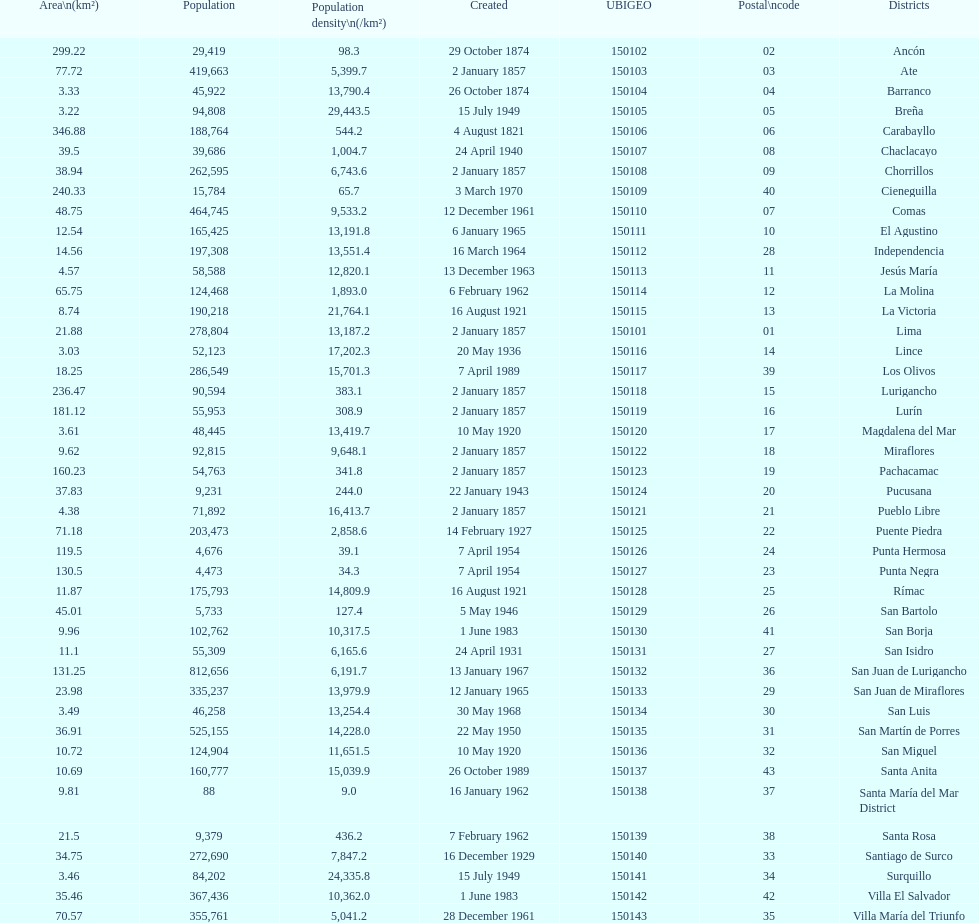Would you mind parsing the complete table? {'header': ['Area\\n(km²)', 'Population', 'Population density\\n(/km²)', 'Created', 'UBIGEO', 'Postal\\ncode', 'Districts'], 'rows': [['299.22', '29,419', '98.3', '29 October 1874', '150102', '02', 'Ancón'], ['77.72', '419,663', '5,399.7', '2 January 1857', '150103', '03', 'Ate'], ['3.33', '45,922', '13,790.4', '26 October 1874', '150104', '04', 'Barranco'], ['3.22', '94,808', '29,443.5', '15 July 1949', '150105', '05', 'Breña'], ['346.88', '188,764', '544.2', '4 August 1821', '150106', '06', 'Carabayllo'], ['39.5', '39,686', '1,004.7', '24 April 1940', '150107', '08', 'Chaclacayo'], ['38.94', '262,595', '6,743.6', '2 January 1857', '150108', '09', 'Chorrillos'], ['240.33', '15,784', '65.7', '3 March 1970', '150109', '40', 'Cieneguilla'], ['48.75', '464,745', '9,533.2', '12 December 1961', '150110', '07', 'Comas'], ['12.54', '165,425', '13,191.8', '6 January 1965', '150111', '10', 'El Agustino'], ['14.56', '197,308', '13,551.4', '16 March 1964', '150112', '28', 'Independencia'], ['4.57', '58,588', '12,820.1', '13 December 1963', '150113', '11', 'Jesús María'], ['65.75', '124,468', '1,893.0', '6 February 1962', '150114', '12', 'La Molina'], ['8.74', '190,218', '21,764.1', '16 August 1921', '150115', '13', 'La Victoria'], ['21.88', '278,804', '13,187.2', '2 January 1857', '150101', '01', 'Lima'], ['3.03', '52,123', '17,202.3', '20 May 1936', '150116', '14', 'Lince'], ['18.25', '286,549', '15,701.3', '7 April 1989', '150117', '39', 'Los Olivos'], ['236.47', '90,594', '383.1', '2 January 1857', '150118', '15', 'Lurigancho'], ['181.12', '55,953', '308.9', '2 January 1857', '150119', '16', 'Lurín'], ['3.61', '48,445', '13,419.7', '10 May 1920', '150120', '17', 'Magdalena del Mar'], ['9.62', '92,815', '9,648.1', '2 January 1857', '150122', '18', 'Miraflores'], ['160.23', '54,763', '341.8', '2 January 1857', '150123', '19', 'Pachacamac'], ['37.83', '9,231', '244.0', '22 January 1943', '150124', '20', 'Pucusana'], ['4.38', '71,892', '16,413.7', '2 January 1857', '150121', '21', 'Pueblo Libre'], ['71.18', '203,473', '2,858.6', '14 February 1927', '150125', '22', 'Puente Piedra'], ['119.5', '4,676', '39.1', '7 April 1954', '150126', '24', 'Punta Hermosa'], ['130.5', '4,473', '34.3', '7 April 1954', '150127', '23', 'Punta Negra'], ['11.87', '175,793', '14,809.9', '16 August 1921', '150128', '25', 'Rímac'], ['45.01', '5,733', '127.4', '5 May 1946', '150129', '26', 'San Bartolo'], ['9.96', '102,762', '10,317.5', '1 June 1983', '150130', '41', 'San Borja'], ['11.1', '55,309', '6,165.6', '24 April 1931', '150131', '27', 'San Isidro'], ['131.25', '812,656', '6,191.7', '13 January 1967', '150132', '36', 'San Juan de Lurigancho'], ['23.98', '335,237', '13,979.9', '12 January 1965', '150133', '29', 'San Juan de Miraflores'], ['3.49', '46,258', '13,254.4', '30 May 1968', '150134', '30', 'San Luis'], ['36.91', '525,155', '14,228.0', '22 May 1950', '150135', '31', 'San Martín de Porres'], ['10.72', '124,904', '11,651.5', '10 May 1920', '150136', '32', 'San Miguel'], ['10.69', '160,777', '15,039.9', '26 October 1989', '150137', '43', 'Santa Anita'], ['9.81', '88', '9.0', '16 January 1962', '150138', '37', 'Santa María del Mar District'], ['21.5', '9,379', '436.2', '7 February 1962', '150139', '38', 'Santa Rosa'], ['34.75', '272,690', '7,847.2', '16 December 1929', '150140', '33', 'Santiago de Surco'], ['3.46', '84,202', '24,335.8', '15 July 1949', '150141', '34', 'Surquillo'], ['35.46', '367,436', '10,362.0', '1 June 1983', '150142', '42', 'Villa El Salvador'], ['70.57', '355,761', '5,041.2', '28 December 1961', '150143', '35', 'Villa María del Triunfo']]} Which district in this city has the greatest population? San Juan de Lurigancho. 